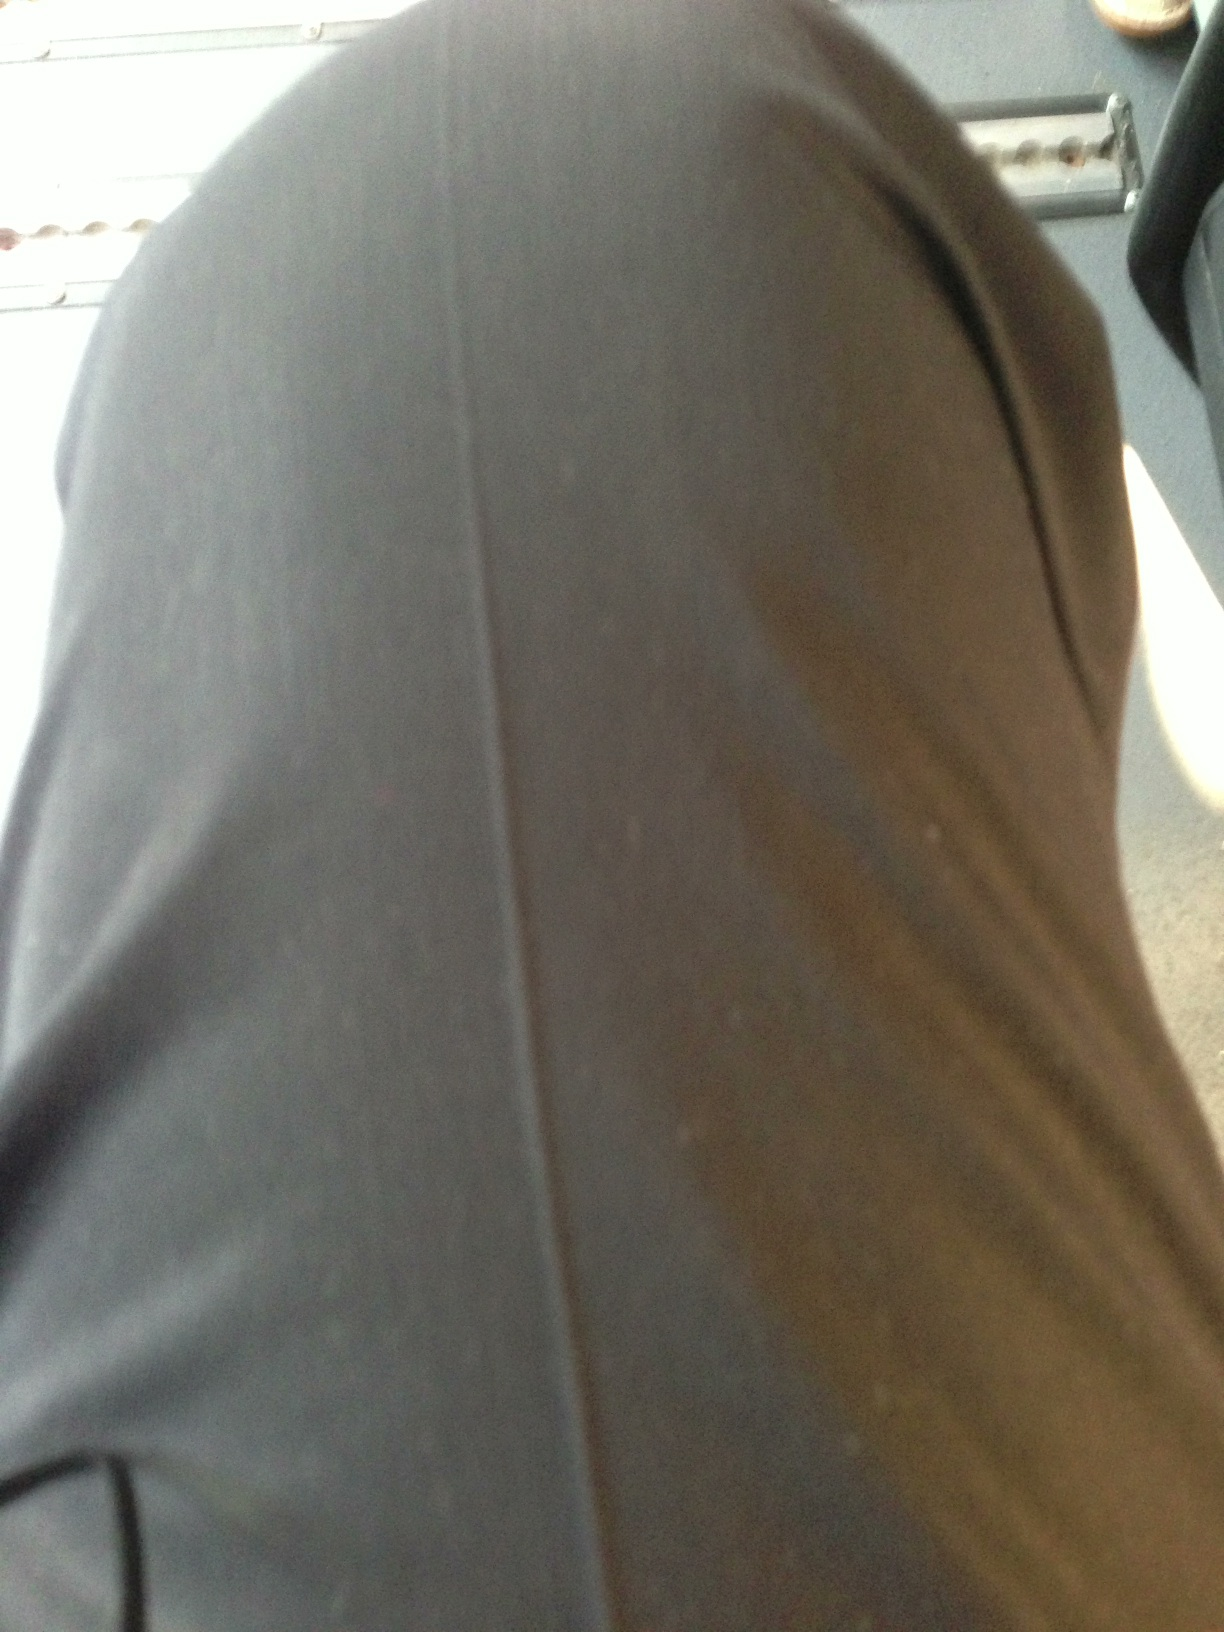What color are these pants? The pants captured in the image are dark grey. This color is versatile and often chosen for its ability to blend well with various shirt colors. 